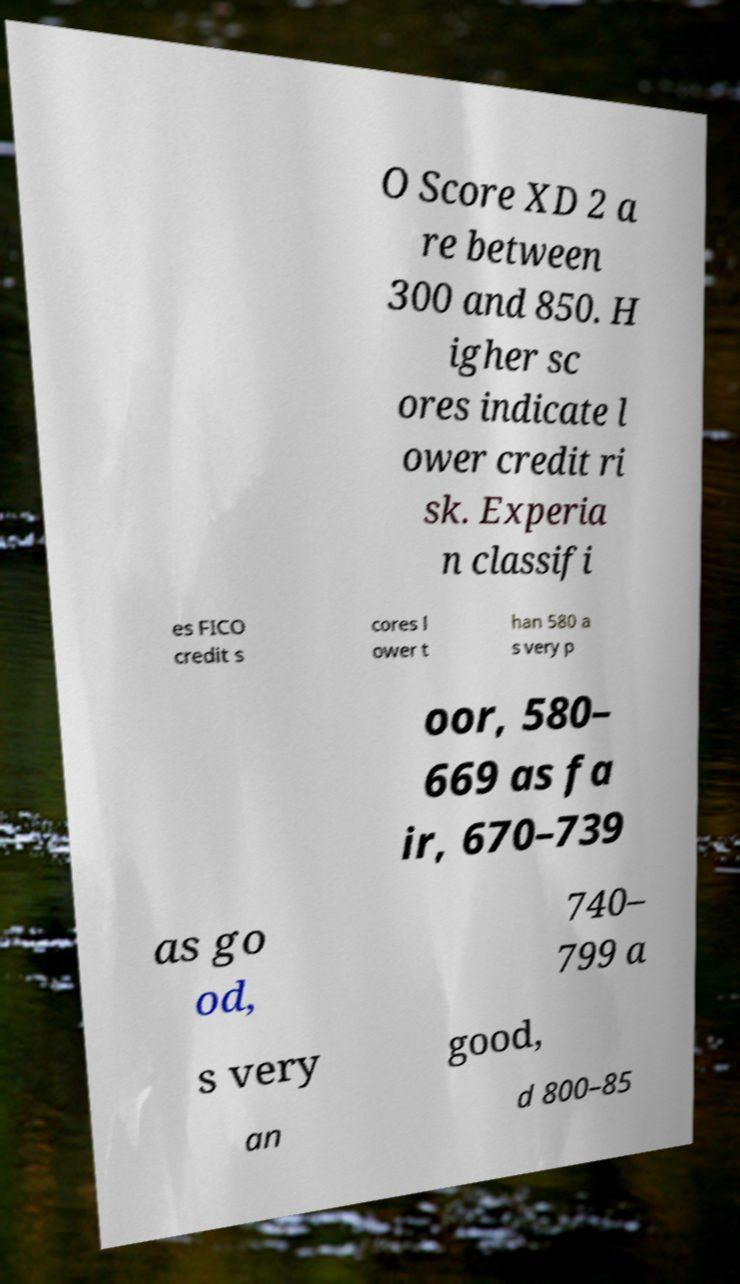Please read and relay the text visible in this image. What does it say? O Score XD 2 a re between 300 and 850. H igher sc ores indicate l ower credit ri sk. Experia n classifi es FICO credit s cores l ower t han 580 a s very p oor, 580– 669 as fa ir, 670–739 as go od, 740– 799 a s very good, an d 800–85 